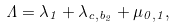<formula> <loc_0><loc_0><loc_500><loc_500>\Lambda = \lambda _ { 1 } + \lambda _ { c , b _ { 2 } } + \mu _ { 0 , 1 } ,</formula> 